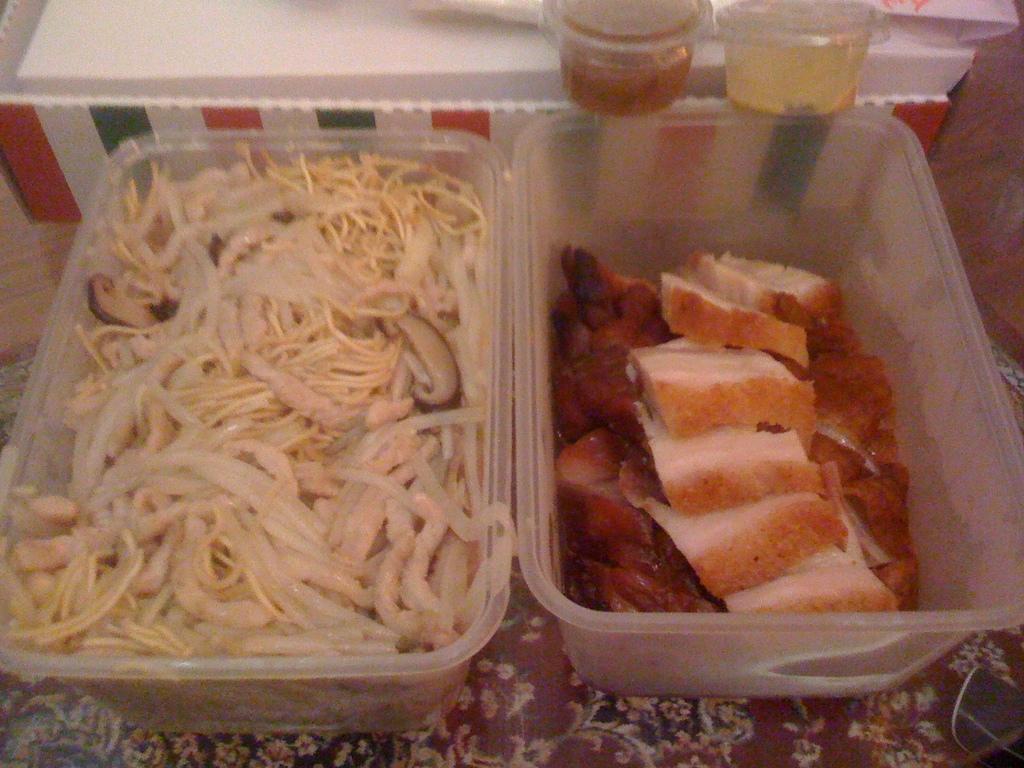How would you summarize this image in a sentence or two? In this image there is a table, on that there are trays, in that trays there is a food item. 